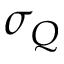Convert formula to latex. <formula><loc_0><loc_0><loc_500><loc_500>\sigma _ { Q }</formula> 